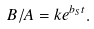Convert formula to latex. <formula><loc_0><loc_0><loc_500><loc_500>B / A = k e ^ { b _ { S } t } .</formula> 